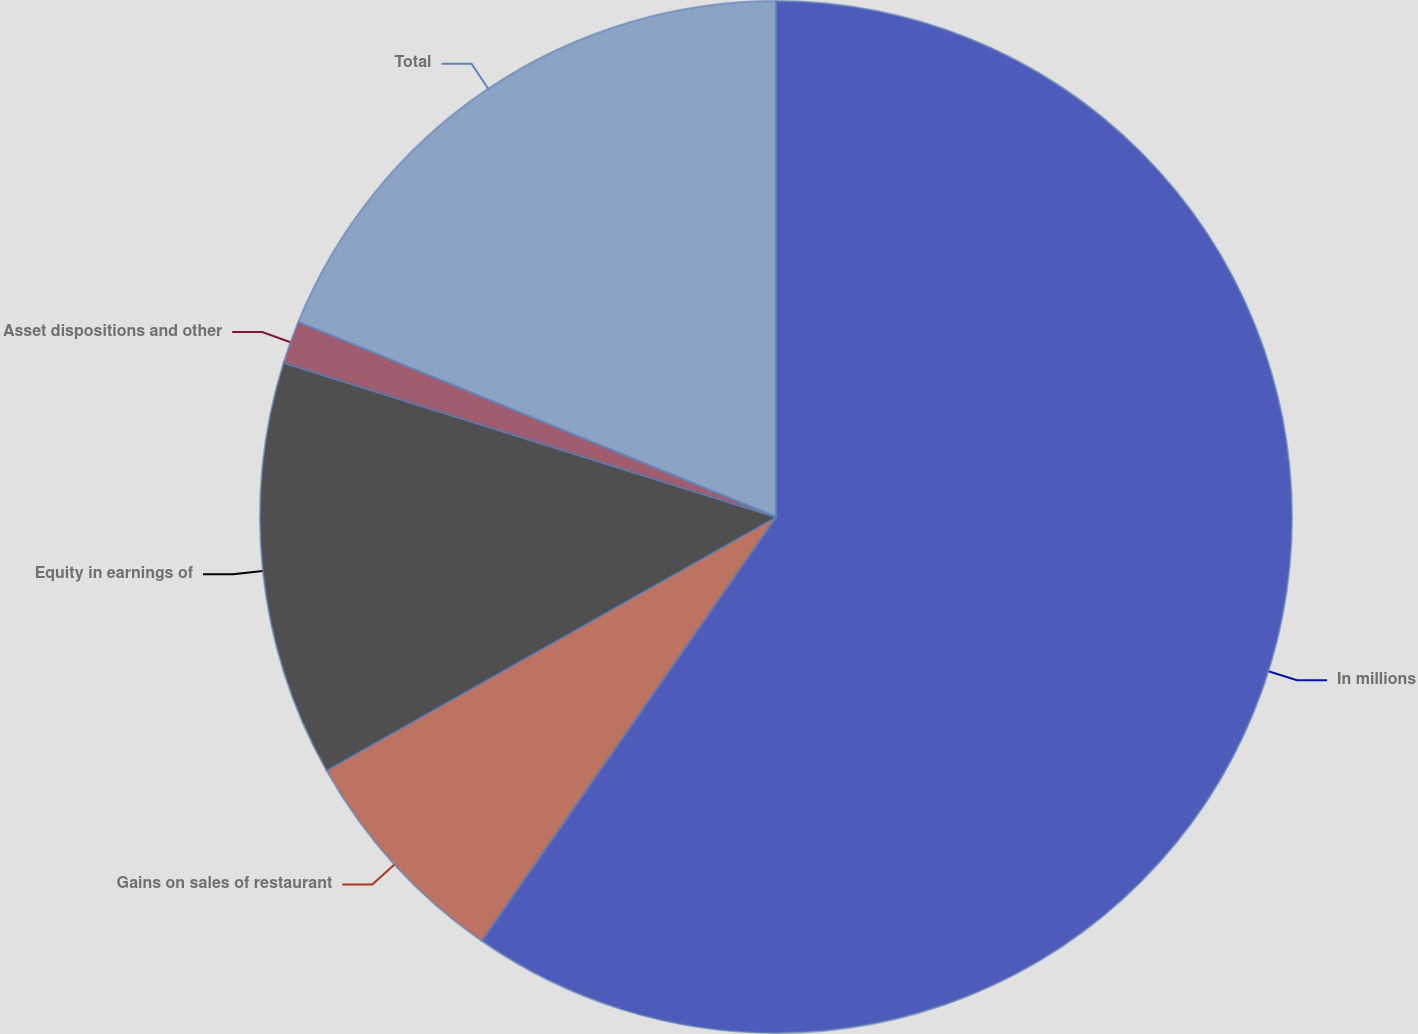Convert chart. <chart><loc_0><loc_0><loc_500><loc_500><pie_chart><fcel>In millions<fcel>Gains on sales of restaurant<fcel>Equity in earnings of<fcel>Asset dispositions and other<fcel>Total<nl><fcel>59.66%<fcel>7.17%<fcel>13.0%<fcel>1.34%<fcel>18.83%<nl></chart> 